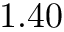<formula> <loc_0><loc_0><loc_500><loc_500>1 . 4 0</formula> 